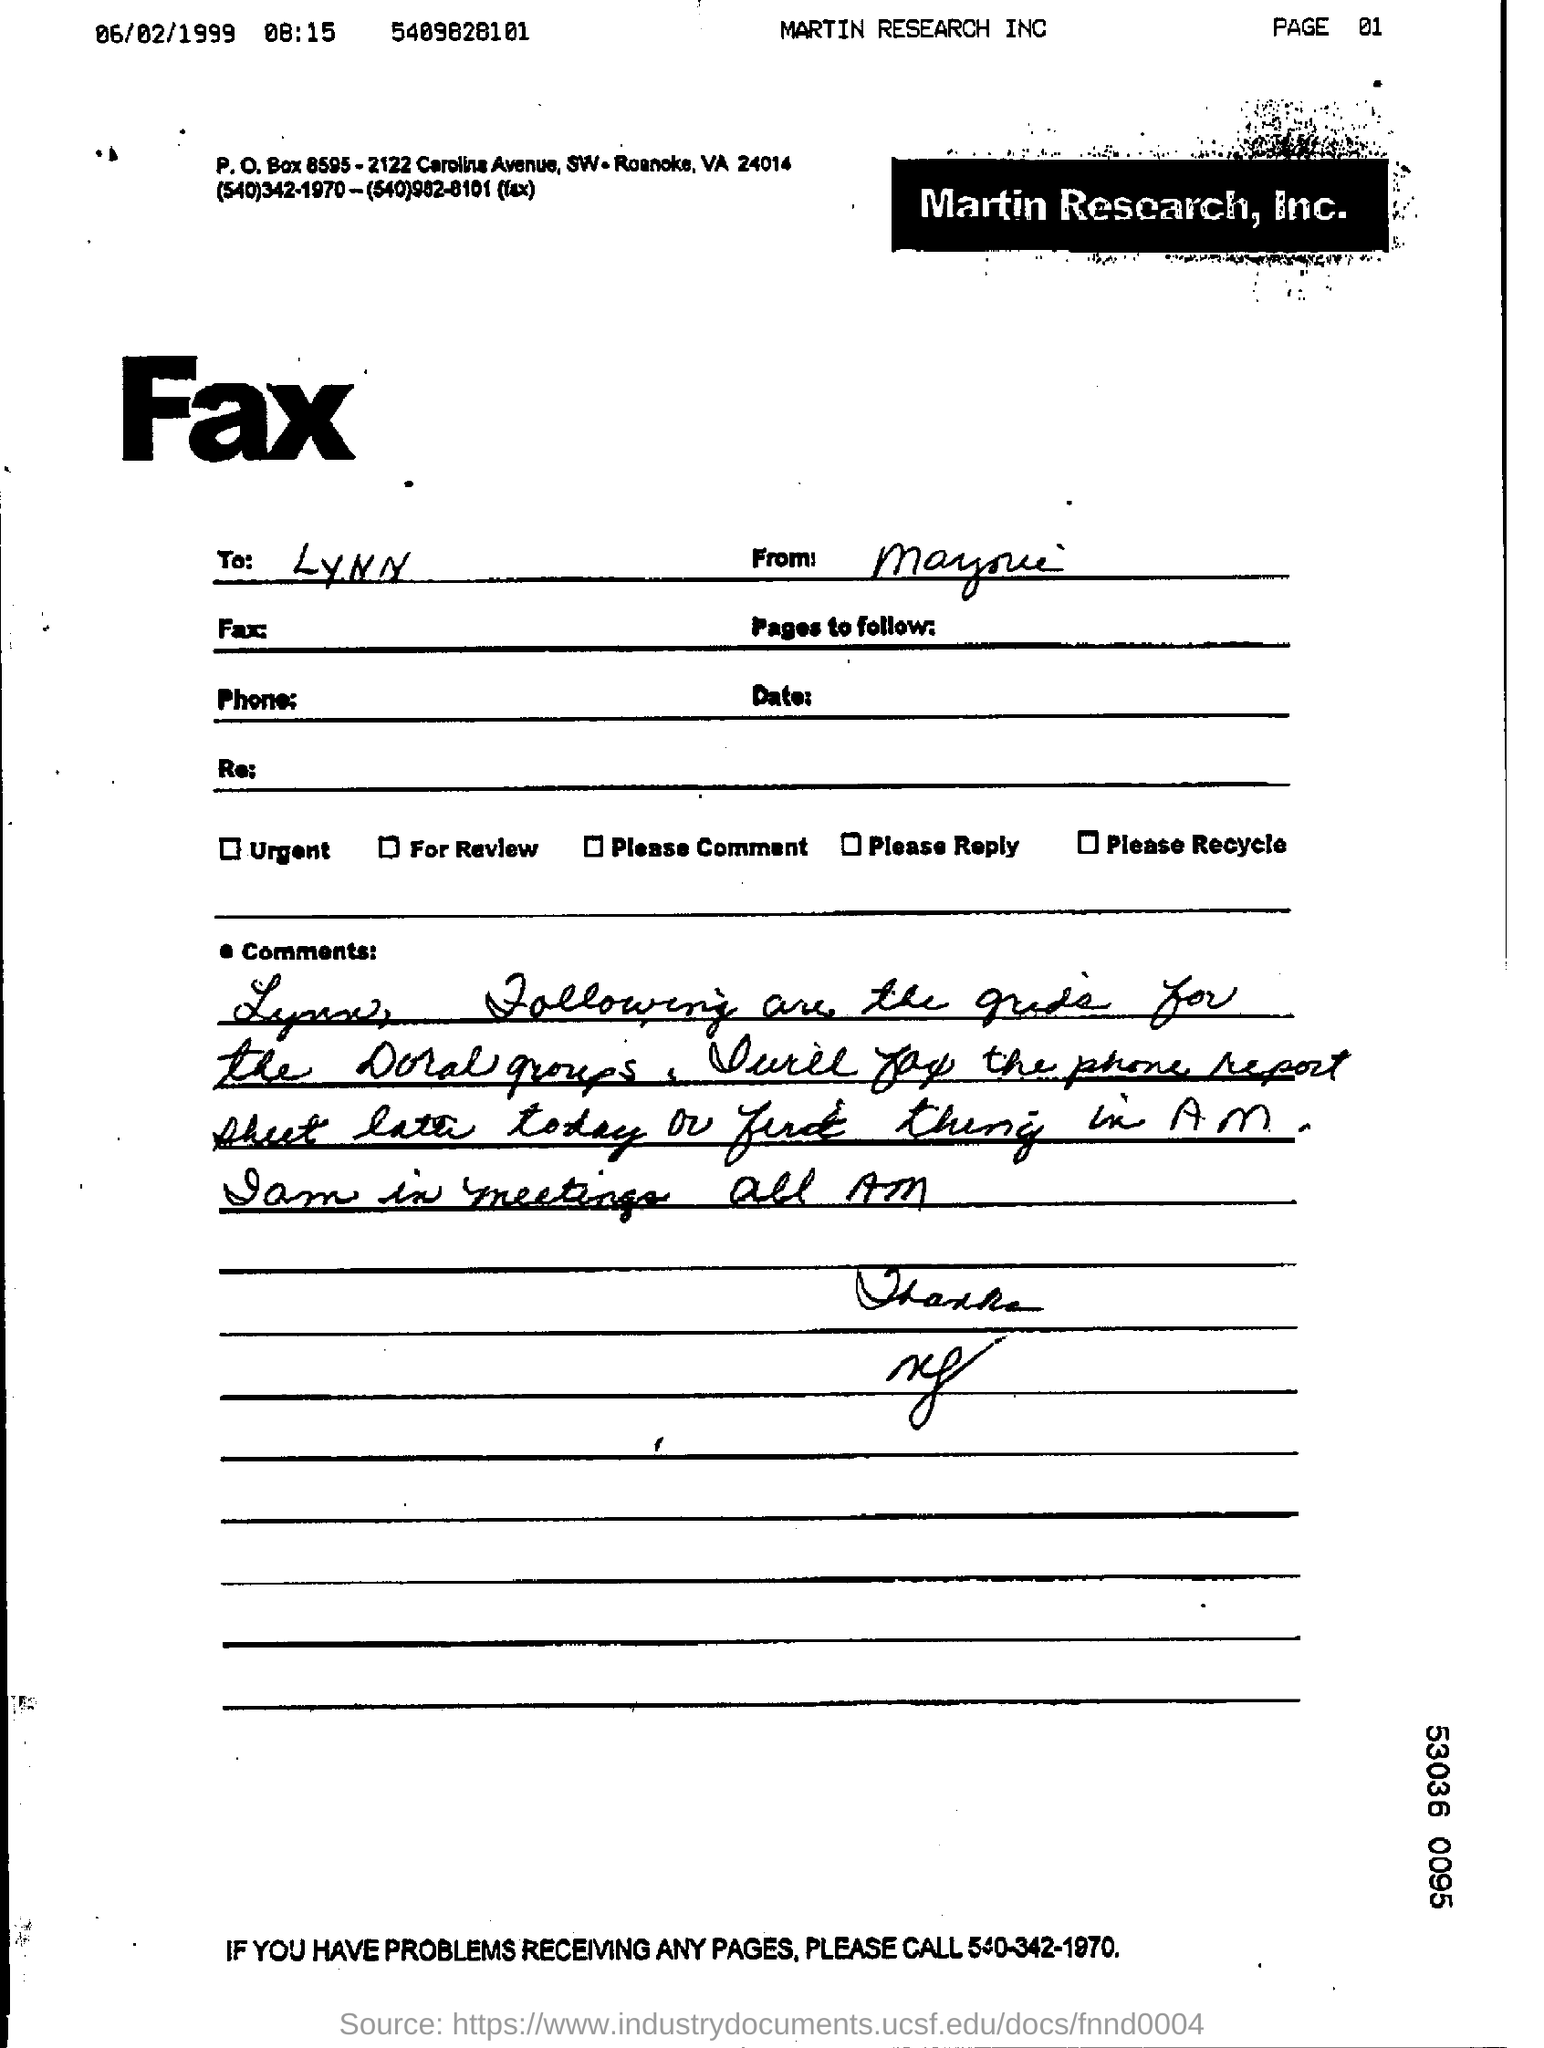Mention a couple of crucial points in this snapshot. The company named Martin Research, Inc. is... The fax is sent to Lynn. 